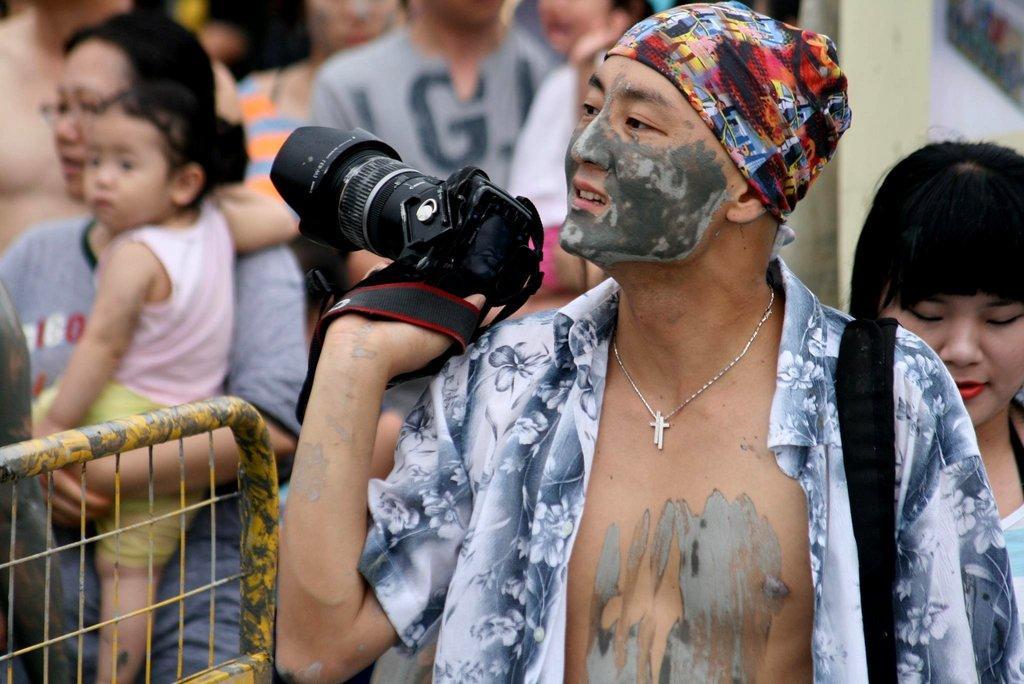How would you summarize this image in a sentence or two? Group of people standing and this person holding camera,this person holding a baby. This is fence. 